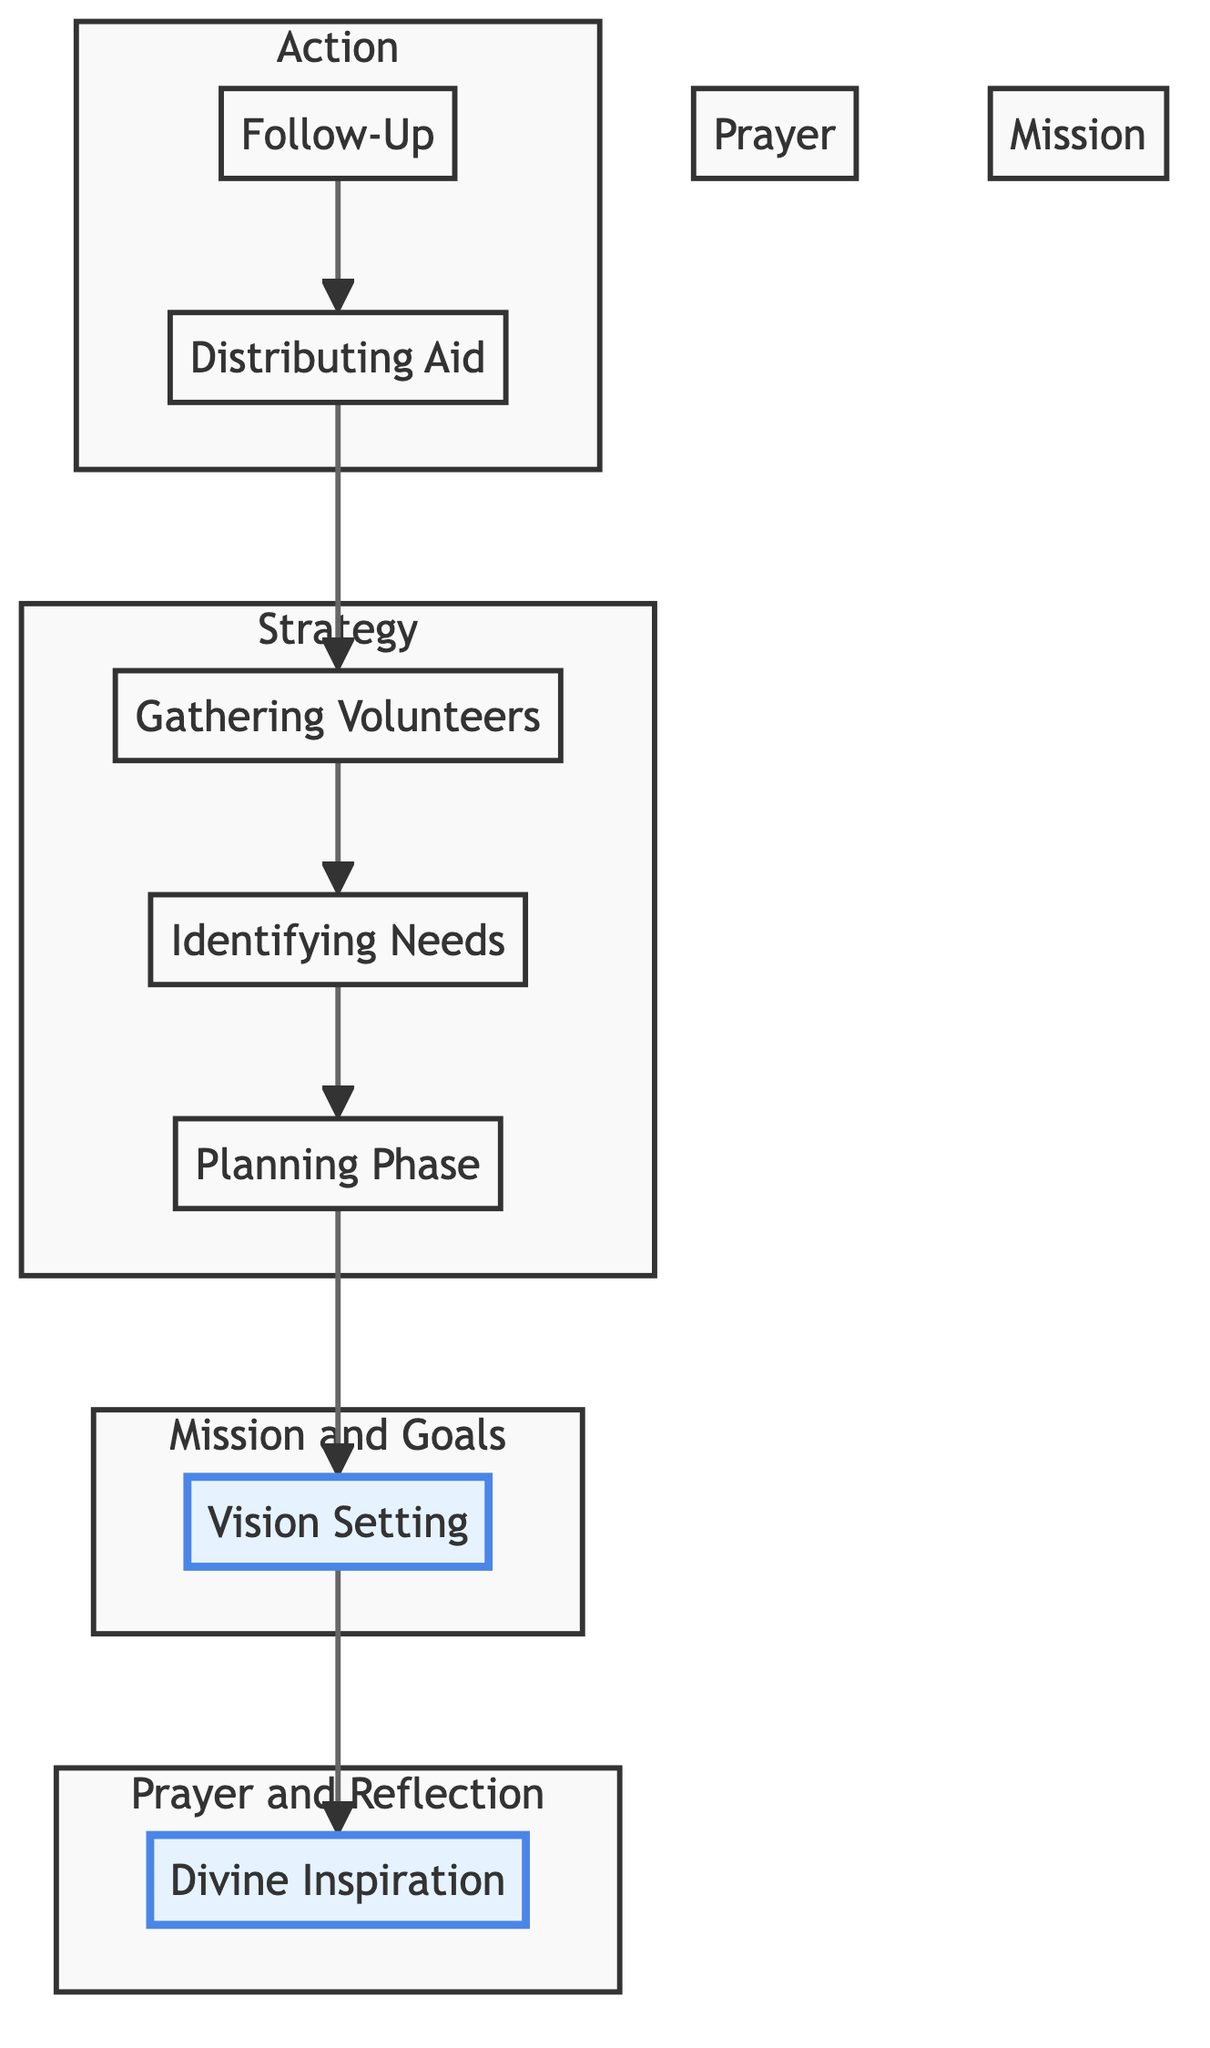What is the final step in the outreach program planning? The diagram shows that the last step is "Follow-Up" when you trace the flow from the bottom to the top.
Answer: Follow-Up How many main phases are there in the outreach program? By counting the distinct nodes in the diagram, there are six main phases represented.
Answer: Six Which step comes immediately before "Distributing Aid"? If you follow the arrows in the diagram, "Gathering Volunteers" directly precedes "Distributing Aid."
Answer: Gathering Volunteers What is the first step in the flow of the outreach program? Starting from the bottom, the first step listed is "Follow-Up," which is the bottom-most node in the flow.
Answer: Follow-Up How does "Vision Setting" relate to "Divine Inspiration"? The diagram indicates that "Vision Setting" follows "Divine Inspiration," showing a direct directional relationship between the two nodes.
Answer: Vision Setting follows Divine Inspiration What are the two highlighted phases in the diagram? Looking at the diagram, "Divine Inspiration" and "Vision Setting" are both highlighted, indicating their importance.
Answer: Divine Inspiration and Vision Setting What is the relationship between "Identifying Needs" and "Planning Phase"? The flow indicates that "Identifying Needs" comes before "Planning Phase," which means that understanding needs is fundamental before planning.
Answer: Identifying Needs comes before Planning Phase What types of activities are included under "Distributing Aid"? The "Distributing Aid" node includes examples such as "Food Drives," "Clothing Distribution," and "Medical Camps."
Answer: Food Drives, Clothing Distribution, Medical Camps Which phase focuses on recruiting help? The node "Gathering Volunteers" is specifically focused on the recruitment of individuals to assist in the outreach program.
Answer: Gathering Volunteers How are "Prayer and Reflection" visually represented in the diagram? "Prayer and Reflection" is represented as a subgraph containing the node "Divine Inspiration," visually distinguishing it from other phases.
Answer: As a subgraph containing Divine Inspiration 